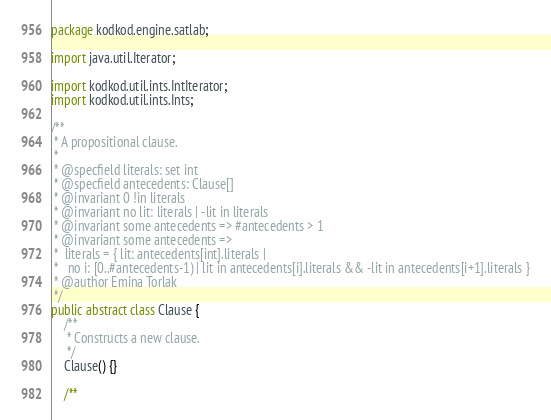Convert code to text. <code><loc_0><loc_0><loc_500><loc_500><_Java_>package kodkod.engine.satlab;

import java.util.Iterator;

import kodkod.util.ints.IntIterator;
import kodkod.util.ints.Ints;

/**
 * A propositional clause.
 * 
 * @specfield literals: set int
 * @specfield antecedents: Clause[]
 * @invariant 0 !in literals 
 * @invariant no lit: literals | -lit in literals
 * @invariant some antecedents => #antecedents > 1
 * @invariant some antecedents => 
 *  literals = { lit: antecedents[int].literals | 
 *   no i: [0..#antecedents-1) | lit in antecedents[i].literals && -lit in antecedents[i+1].literals }
 * @author Emina Torlak
 */
public abstract class Clause {
	/**
	 * Constructs a new clause.
	 */
	Clause() {}
		
	/**</code> 